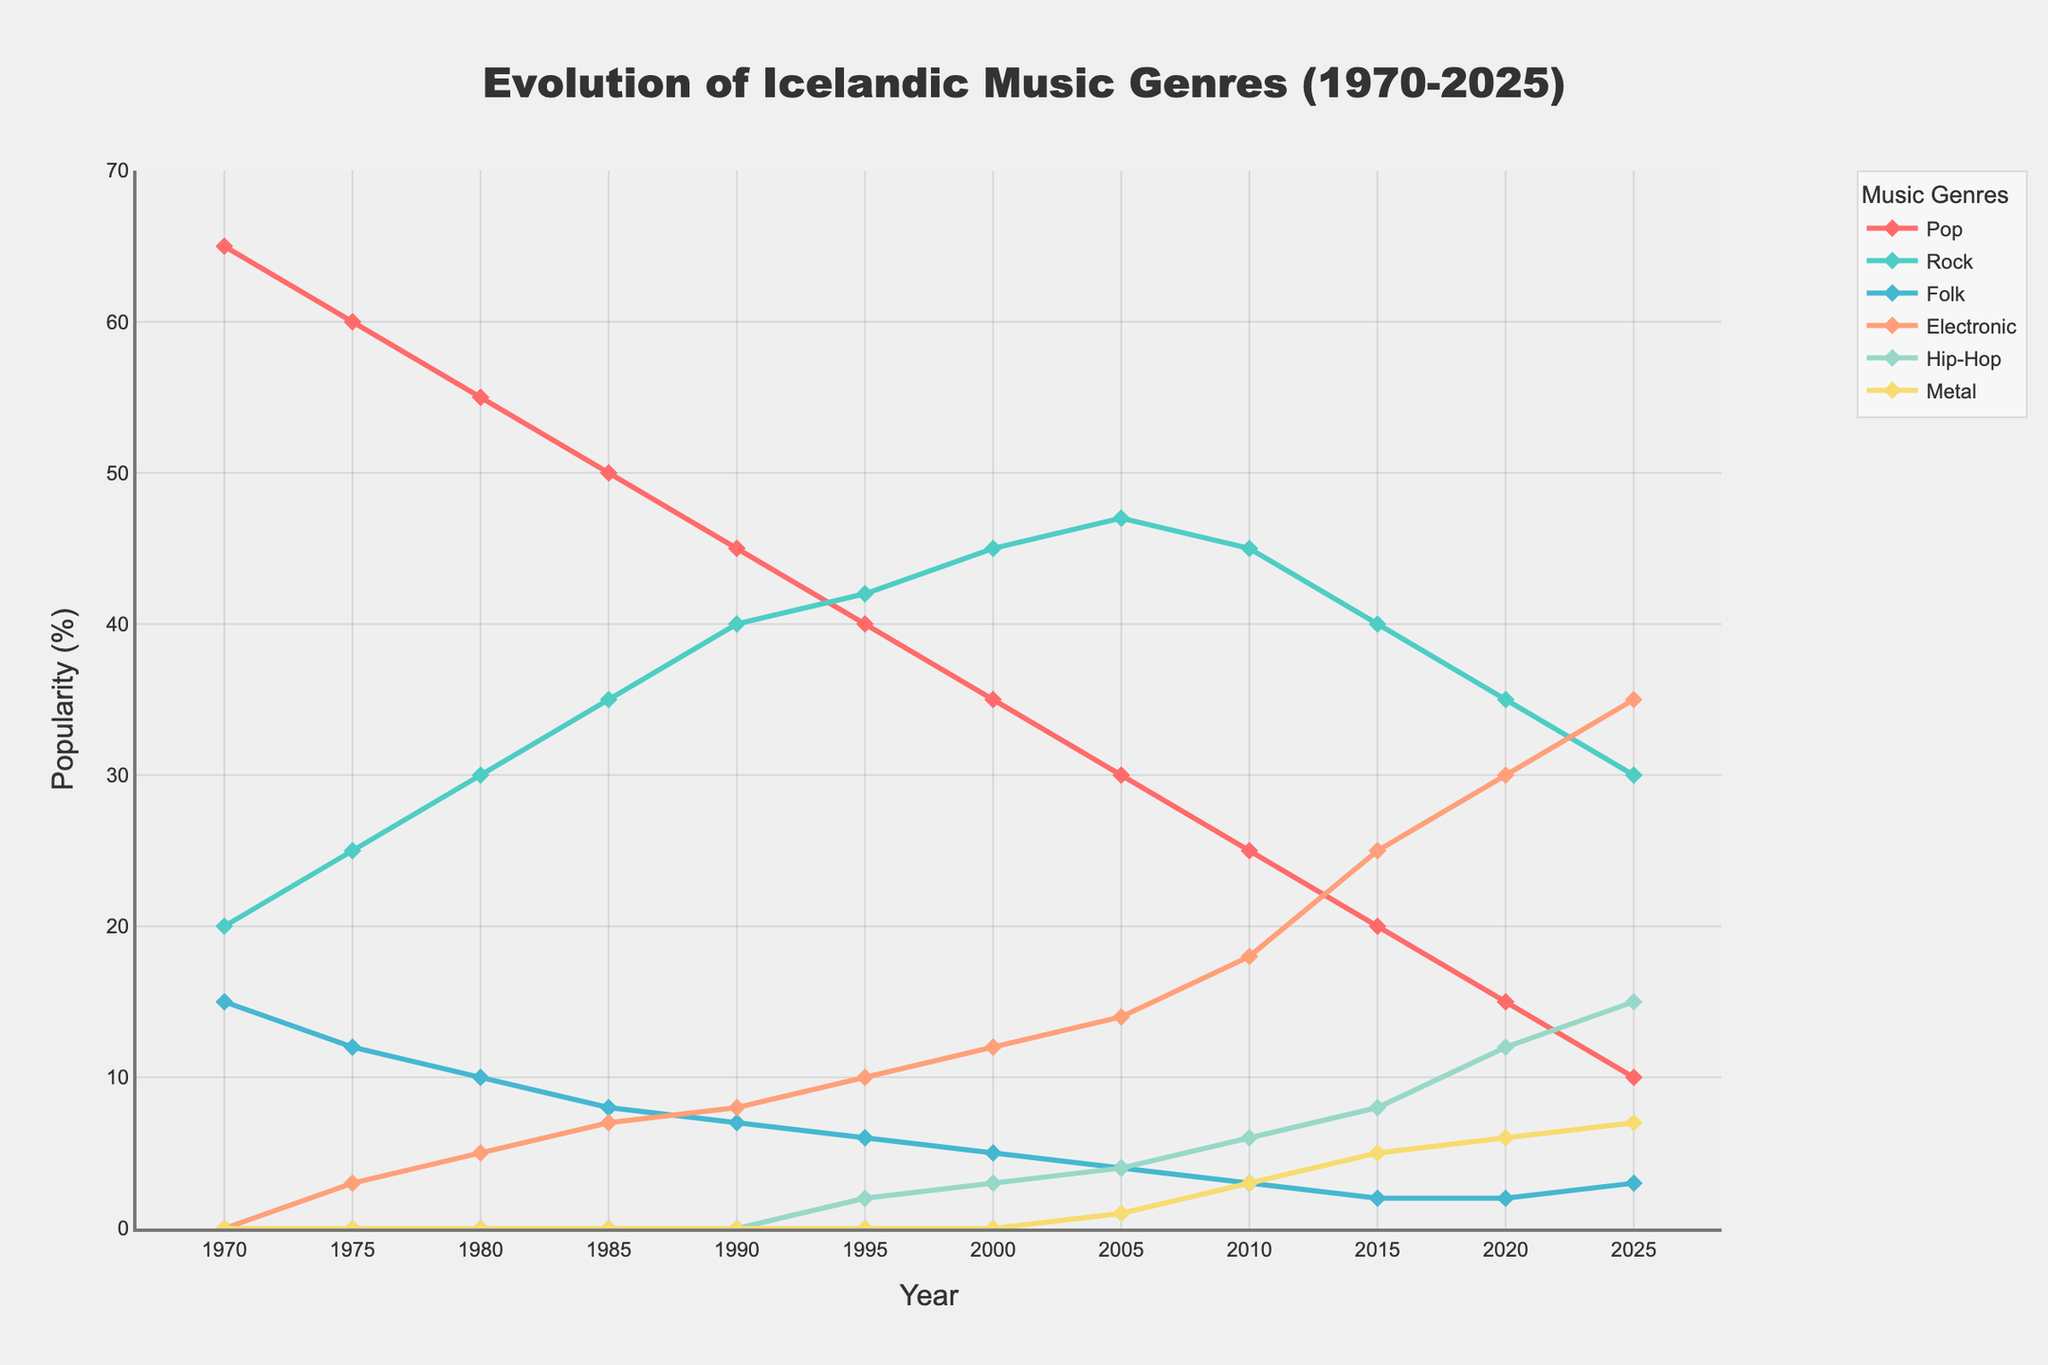What genre reaches its peak popularity in 2025? Electronic music enjoys the highest popularity in 2025, peaking at 35%.
Answer: Electronic music Which genre shows the greatest decline from 1970 to 2025? Pop music declines from 65% in 1970 to 10% in 2025, showing a reduction of 55 percentage points.
Answer: Pop music Between 2000 and 2010, which genre experiences the highest growth? Electronic music grows from 12% in 2000 to 18% in 2010, marking a 6 percentage points increase.
Answer: Electronic music Compare the popularity of Folk music in 1970 vs 2025. Which year is it more popular, and by how much? In 1970, Folk music has a popularity of 15%, and in 2025, it is 3%. Therefore, it was more popular in 1970 by 12 percentage points.
Answer: 1970, by 12 percentage points What is the combined popularity percentage of Rock and Hip-Hop by the year 2020? Rock music is 35% and Hip-Hop is 12% in 2020. Their combined popularity is 35% + 12% = 47%.
Answer: 47% During which period did Metal genres emerge and what was their initial popularity percentage? Metal music first appears in 2005 with a popularity of 1%.
Answer: 2005, 1% How does the popularity of Hip-Hop in 1995 compare to that in 2025? In 1995, Hip-Hop popularity is 2%, and it rises to 15% in 2025, increasing by 13 percentage points over that period.
Answer: Increased by 13 percentage points Which genre was more popular in 1990: Rock or Pop? By how much? In 1990, Rock had a popularity of 40%, whereas Pop had 45%. Pop was more popular by 5 percentage points.
Answer: Pop, by 5 percentage points Looking at the span from 1970 to 2025, which genre has the most stable popularity? Folk music has seen the least fluctuation in popularity, starting at 15% in 1970 and ending at 3% in 2025 with slight variations in between.
Answer: Folk music 